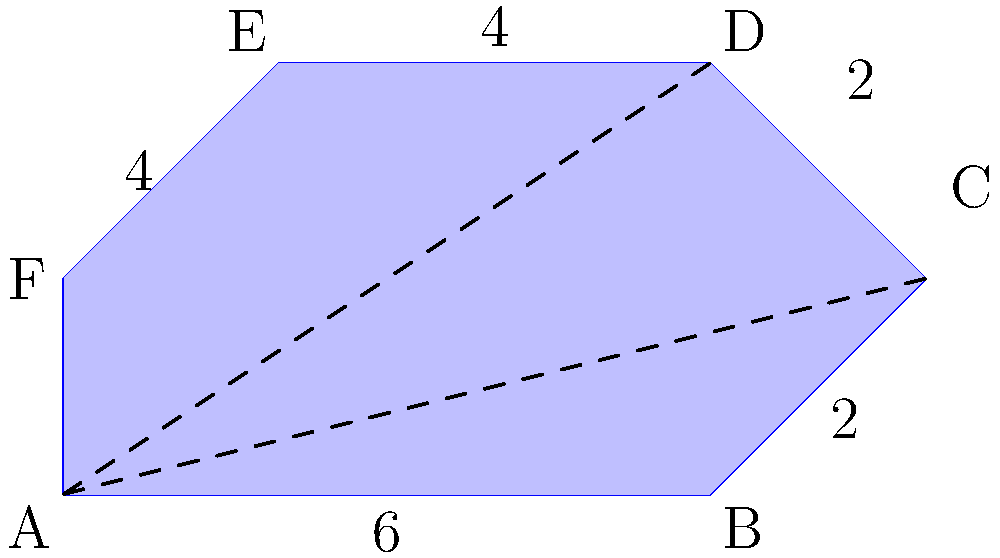As part of your marine biology research, you're studying an irregular-shaped coral reef. To estimate its area, you decide to use geometric approximations. The reef can be approximated by the shape shown in the diagram. If the length of the base (AB) is 6 units and the height (EF) is 4 units, calculate the total area of the reef using two triangles and a rectangle. Round your answer to the nearest whole number. To calculate the area of the irregular-shaped coral reef, we'll divide it into simpler geometric shapes: two triangles and a rectangle. Let's follow these steps:

1. Identify the shapes:
   - Triangle 1: ABC
   - Rectangle: ACDF
   - Triangle 2: CDE

2. Calculate the area of Triangle 1 (ABC):
   Base = 6 units, Height = 2 units
   Area of Triangle 1 = $\frac{1}{2} \times base \times height = \frac{1}{2} \times 6 \times 2 = 6$ square units

3. Calculate the area of the Rectangle (ACDF):
   Length = 6 units, Width = 2 units
   Area of Rectangle = $length \times width = 6 \times 2 = 12$ square units

4. Calculate the area of Triangle 2 (CDE):
   Base = 2 units, Height = 2 units
   Area of Triangle 2 = $\frac{1}{2} \times base \times height = \frac{1}{2} \times 2 \times 2 = 2$ square units

5. Sum up the areas:
   Total Area = Area of Triangle 1 + Area of Rectangle + Area of Triangle 2
               = $6 + 12 + 2 = 20$ square units

Therefore, the total area of the coral reef is approximately 20 square units.
Answer: 20 square units 